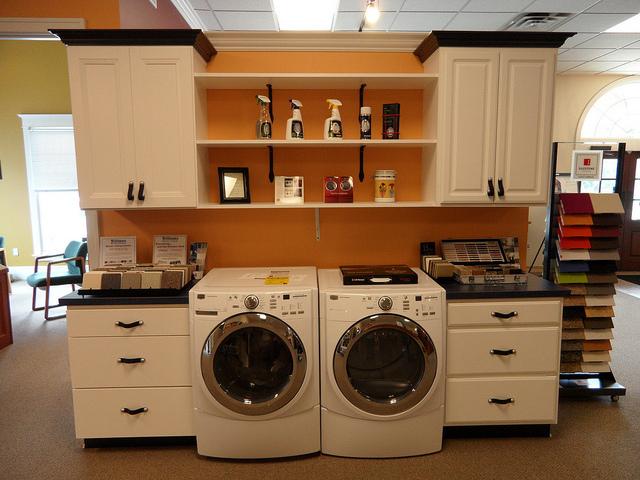Are these washing machines?
Quick response, please. Yes. Is this a store display or a residence?
Keep it brief. Store display. What is sitting above the dryer?
Keep it brief. Shelf. Where is the room?
Short answer required. Store. 